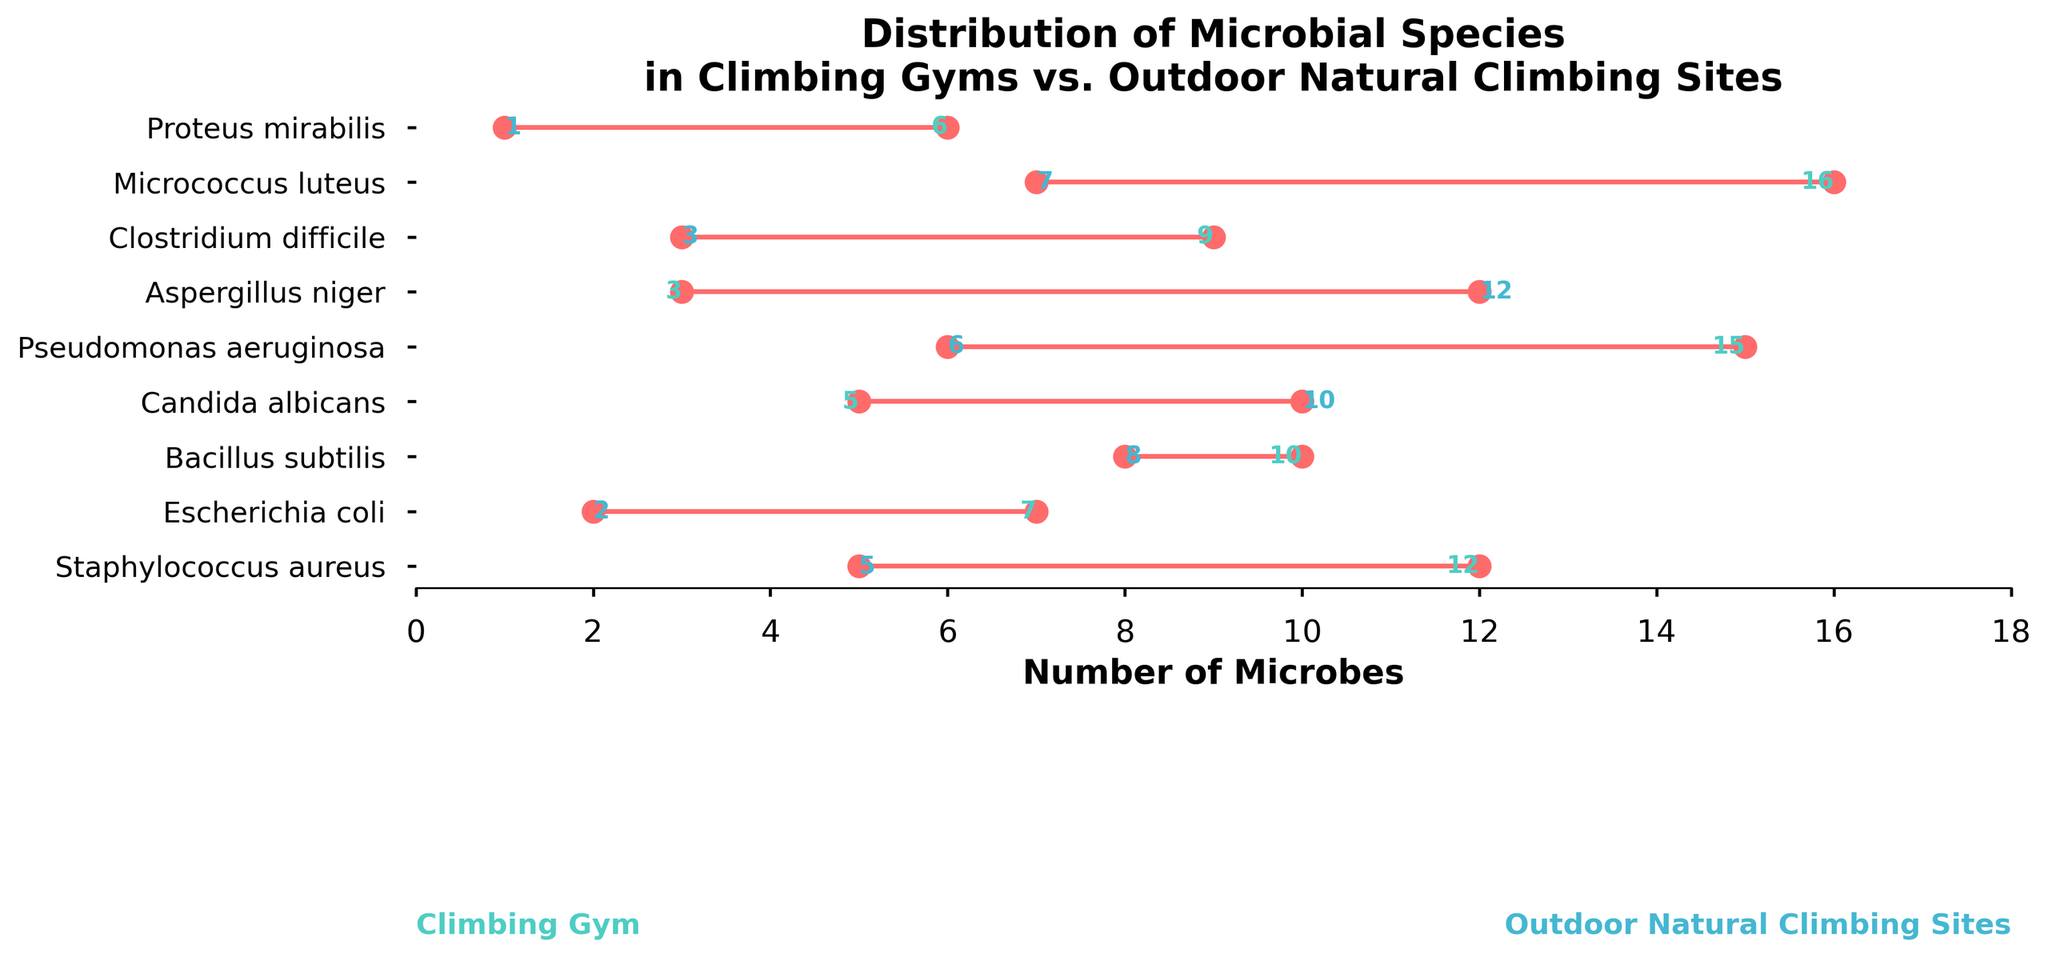What's the title of the figure? The title is located at the top of the figure. It succinctly describes the contents and purpose of the plot.
Answer: Distribution of Microbial Species in Climbing Gyms vs. Outdoor Natural Climbing Sites What are the x-axis labels representing? The x-axis is labeled "Number of Microbes," meaning it represents the quantitative count of microbial species in both environments.
Answer: Number of Microbes Which microbial species has the highest count in climbing gyms? By observing the length of the bars on the left side, we see the longest bar corresponds to Micrococcus luteus.
Answer: Micrococcus luteus Which microbial species has a higher count in outdoor natural climbing sites compared to climbing gyms? Candida albicans and Aspergillus niger have higher counts in outdoor natural climbing sites than in climbing gyms, as their bars on the right side are longer than those on the left.
Answer: Candida albicans and Aspergillus niger What's the difference in the count of Staphylococcus aureus between climbing gyms and outdoor natural climbing sites? Staphylococcus aureus has counts of 12 in climbing gyms and 5 in outdoor sites. The difference is calculated as 12 - 5.
Answer: 7 What’s the sum of the counts of Escherichia coli in both environments? The count of Escherichia coli in climbing gyms is 7 and in outdoor natural climbing sites is 2. The sum is 7 + 2.
Answer: 9 Which microbial species has the closest counts in both environments? Bacillus subtilis has counts of 10 in climbing gyms and 8 in outdoor sites, making the difference small compared to other species.
Answer: Bacillus subtilis How many microbial species have a higher count in climbing gyms compared to outdoor natural climbing sites? By comparing the counts, Staphylococcus aureus, Escherichia coli, Pseudomonas aeruginosa, Clostridium difficile, and Micrococcus luteus have higher counts in climbing gyms.
Answer: 5 Which microbial species has the maximum difference in counts between the two environments? Pseudomonas aeruginosa has counts of 15 in climbing gyms and 6 in outdoor sites, with a difference of 9. This is the largest observed difference.
Answer: Pseudomonas aeruginosa What's the average count of Aspergillus niger across both environments? Aspergillus niger has 3 in climbing gyms and 12 in outdoor sites, summing to 15. The average is calculated as 15/2.
Answer: 7.5 